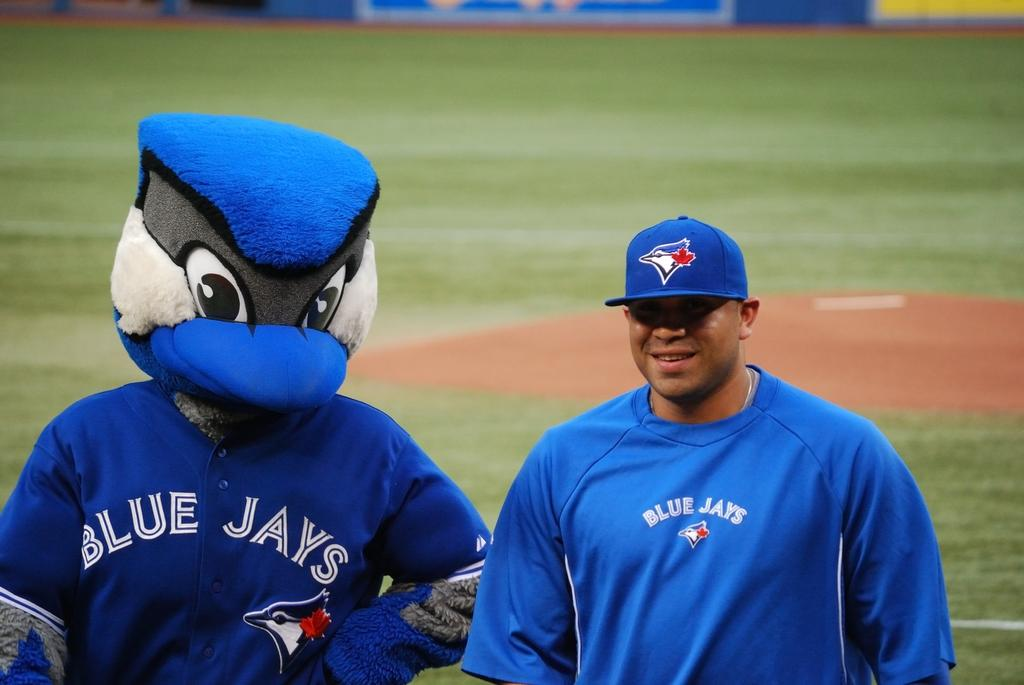How many people are present in the image? There are two persons standing in the image. What is distinctive about one of the person's attire? One person is wearing a costume. What type of environment is visible in the background of the image? There is a grass field in the background of the image. What else can be seen in the background of the image? There are boards visible in the background of the image. What type of ink is being used by the babies in the image? There are no babies present in the image, so there is no ink being used. 